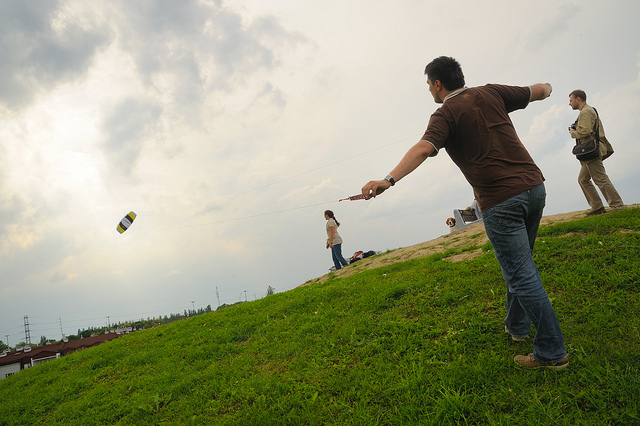How many people are visible? 2 